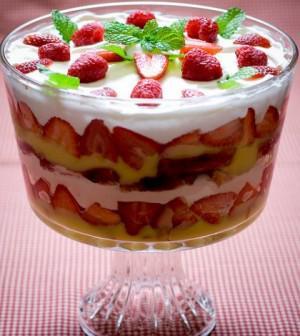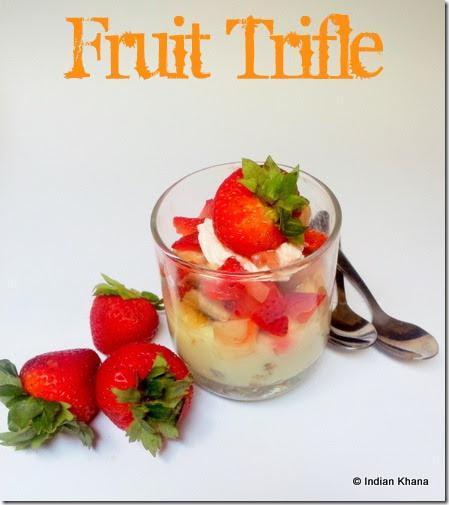The first image is the image on the left, the second image is the image on the right. For the images displayed, is the sentence "There are spoons resting next to a cup of trifle." factually correct? Answer yes or no. Yes. 